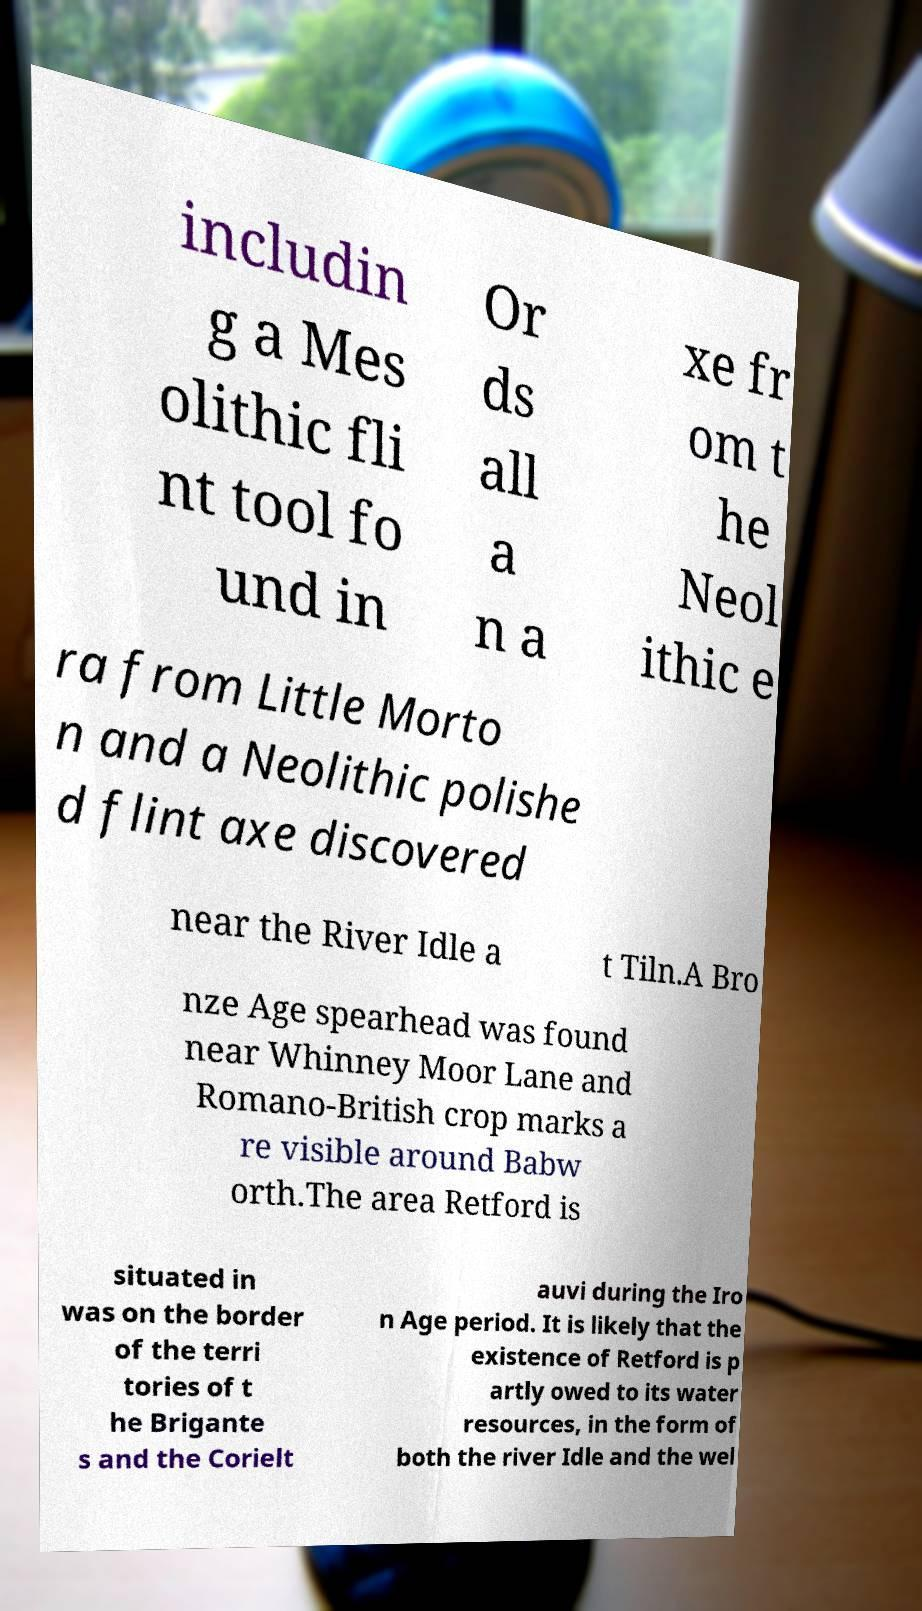Can you accurately transcribe the text from the provided image for me? includin g a Mes olithic fli nt tool fo und in Or ds all a n a xe fr om t he Neol ithic e ra from Little Morto n and a Neolithic polishe d flint axe discovered near the River Idle a t Tiln.A Bro nze Age spearhead was found near Whinney Moor Lane and Romano-British crop marks a re visible around Babw orth.The area Retford is situated in was on the border of the terri tories of t he Brigante s and the Corielt auvi during the Iro n Age period. It is likely that the existence of Retford is p artly owed to its water resources, in the form of both the river Idle and the wel 